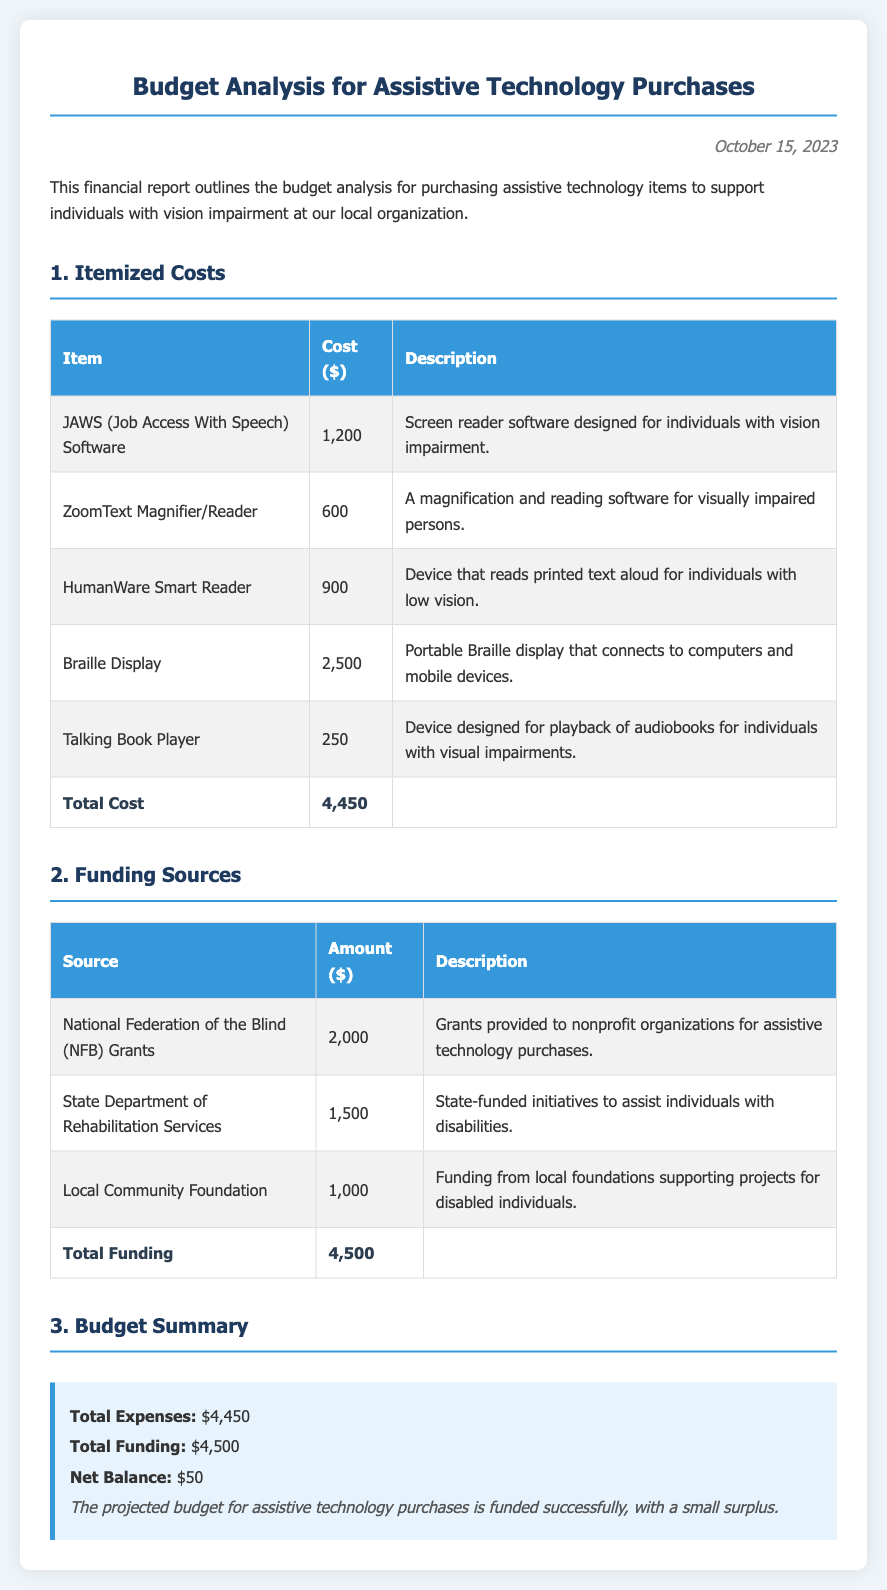What is the total cost of assistive technology items? The total cost is listed at the bottom of the Itemized Costs table, which adds up all individual costs.
Answer: 4,450 What is the funding amount from the National Federation of the Blind (NFB)? The funding amount from the NFB is specified in the Funding Sources table.
Answer: 2,000 What assistive technology costs the most? The item with the highest cost is identified in the Itemized Costs table.
Answer: Braille Display What is the date of the budget analysis report? The date is mentioned at the top of the report.
Answer: October 15, 2023 What is the net balance from the budget summary? The net balance is calculated from total expenses and total funding in the Budget Summary section.
Answer: 50 How much funding is provided by the Local Community Foundation? The amount from the Local Community Foundation is outlined in the Funding Sources table.
Answer: 1,000 What is the total funding amount? The total funding is shown at the end of the Funding Sources table, summarizing all sources.
Answer: 4,500 What is the purpose of the report? The purpose of the report is stated at the beginning of the document.
Answer: Budget analysis for purchasing assistive technology 